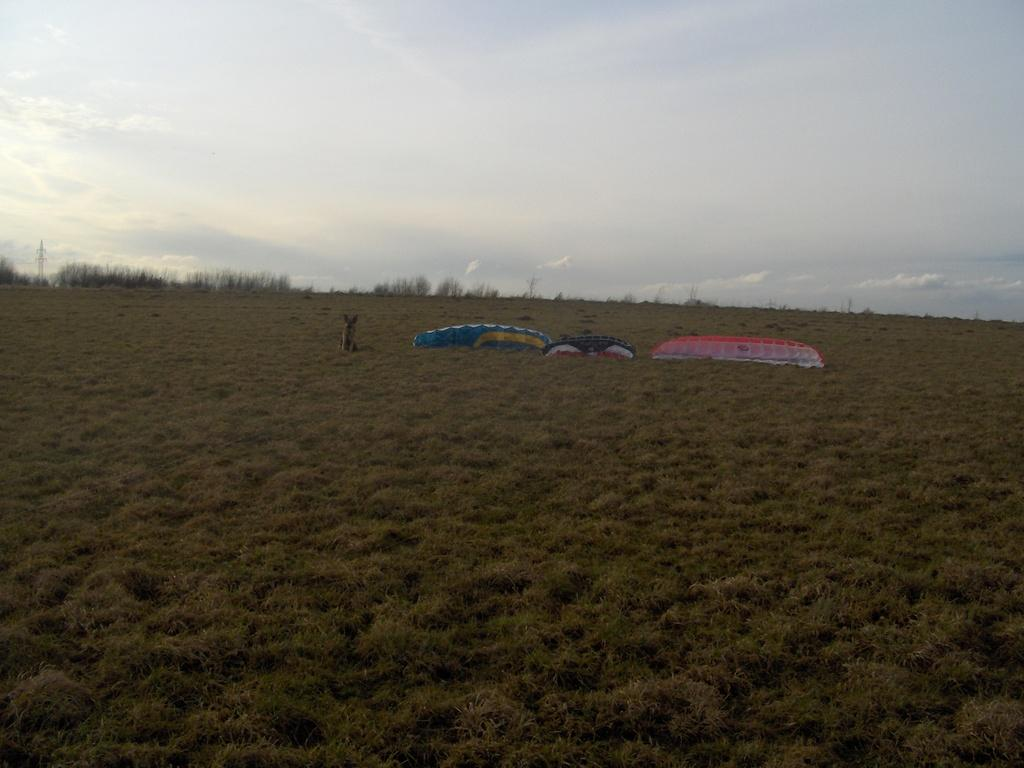What type of landscape is depicted in the image? There is a grassland in the image. What kind of living creature can be seen in the image? There is an animal in the image. What else is present in the image besides the grassland and animal? There are some objects in the image. What can be seen in the background of the image? The sky is visible in the background of the image, and there are clouds in the sky. What type of bone can be seen in the image? There is no bone present in the image. What phase of the moon is visible in the image? The image does not depict the moon; it shows a grassland, an animal, objects, and a sky with clouds. 